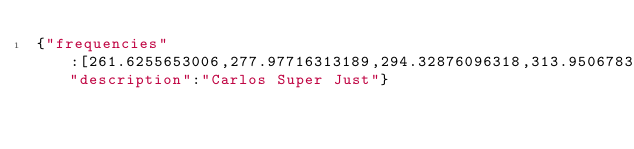Convert code to text. <code><loc_0><loc_0><loc_500><loc_500><_JavaScript_>{"frequencies":[261.6255653006,277.97716313189,294.32876096318,313.95067836072,327.03195662575,348.83408706747,359.73515228832,392.4383479509,425.14154361347,436.04260883433,457.84473927605,490.54793493862,523.2511306012],"description":"Carlos Super Just"}</code> 